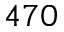<formula> <loc_0><loc_0><loc_500><loc_500>4 7 0</formula> 